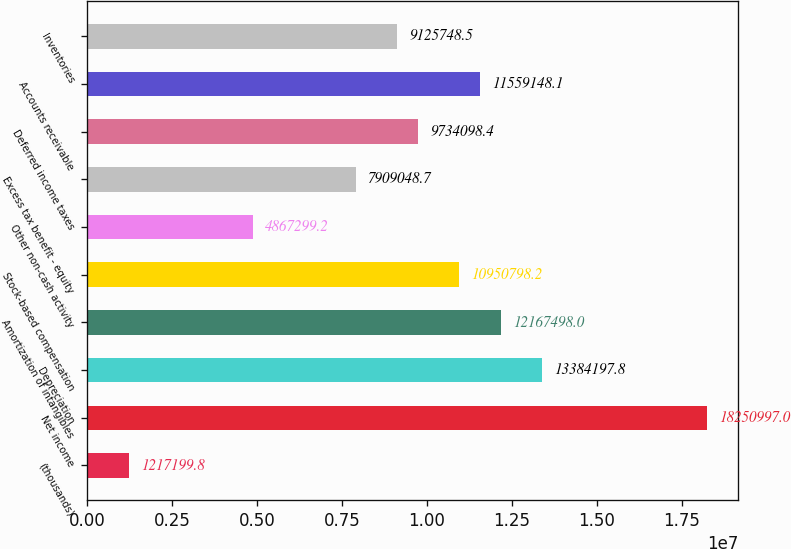<chart> <loc_0><loc_0><loc_500><loc_500><bar_chart><fcel>(thousands)<fcel>Net income<fcel>Depreciation<fcel>Amortization of intangibles<fcel>Stock-based compensation<fcel>Other non-cash activity<fcel>Excess tax benefit - equity<fcel>Deferred income taxes<fcel>Accounts receivable<fcel>Inventories<nl><fcel>1.2172e+06<fcel>1.8251e+07<fcel>1.33842e+07<fcel>1.21675e+07<fcel>1.09508e+07<fcel>4.8673e+06<fcel>7.90905e+06<fcel>9.7341e+06<fcel>1.15591e+07<fcel>9.12575e+06<nl></chart> 